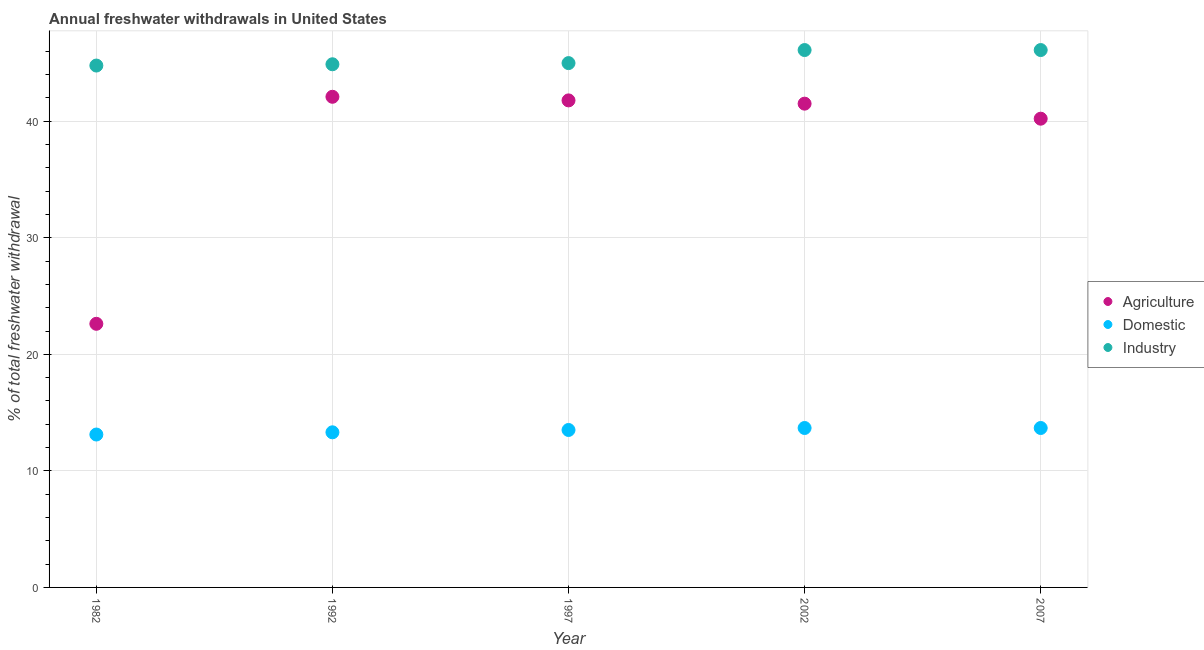Is the number of dotlines equal to the number of legend labels?
Your answer should be very brief. Yes. What is the percentage of freshwater withdrawal for industry in 2002?
Your response must be concise. 46.11. Across all years, what is the maximum percentage of freshwater withdrawal for agriculture?
Provide a succinct answer. 42.1. Across all years, what is the minimum percentage of freshwater withdrawal for agriculture?
Make the answer very short. 22.62. What is the total percentage of freshwater withdrawal for agriculture in the graph?
Your response must be concise. 188.24. What is the difference between the percentage of freshwater withdrawal for industry in 1997 and that in 2002?
Ensure brevity in your answer.  -1.12. What is the difference between the percentage of freshwater withdrawal for industry in 1982 and the percentage of freshwater withdrawal for domestic purposes in 2007?
Offer a terse response. 31.1. What is the average percentage of freshwater withdrawal for agriculture per year?
Offer a very short reply. 37.65. In the year 1992, what is the difference between the percentage of freshwater withdrawal for domestic purposes and percentage of freshwater withdrawal for agriculture?
Your answer should be compact. -28.79. In how many years, is the percentage of freshwater withdrawal for industry greater than 20 %?
Your answer should be very brief. 5. What is the ratio of the percentage of freshwater withdrawal for domestic purposes in 1992 to that in 2002?
Keep it short and to the point. 0.97. Is the difference between the percentage of freshwater withdrawal for agriculture in 1982 and 2002 greater than the difference between the percentage of freshwater withdrawal for domestic purposes in 1982 and 2002?
Your response must be concise. No. What is the difference between the highest and the second highest percentage of freshwater withdrawal for domestic purposes?
Make the answer very short. 0. What is the difference between the highest and the lowest percentage of freshwater withdrawal for agriculture?
Ensure brevity in your answer.  19.48. Is the sum of the percentage of freshwater withdrawal for industry in 1997 and 2002 greater than the maximum percentage of freshwater withdrawal for agriculture across all years?
Give a very brief answer. Yes. Is the percentage of freshwater withdrawal for industry strictly greater than the percentage of freshwater withdrawal for domestic purposes over the years?
Ensure brevity in your answer.  Yes. What is the difference between two consecutive major ticks on the Y-axis?
Your answer should be very brief. 10. How many legend labels are there?
Your response must be concise. 3. How are the legend labels stacked?
Keep it short and to the point. Vertical. What is the title of the graph?
Your response must be concise. Annual freshwater withdrawals in United States. Does "Wage workers" appear as one of the legend labels in the graph?
Keep it short and to the point. No. What is the label or title of the Y-axis?
Offer a very short reply. % of total freshwater withdrawal. What is the % of total freshwater withdrawal of Agriculture in 1982?
Give a very brief answer. 22.62. What is the % of total freshwater withdrawal in Domestic in 1982?
Ensure brevity in your answer.  13.12. What is the % of total freshwater withdrawal in Industry in 1982?
Provide a short and direct response. 44.78. What is the % of total freshwater withdrawal of Agriculture in 1992?
Offer a very short reply. 42.1. What is the % of total freshwater withdrawal in Domestic in 1992?
Provide a succinct answer. 13.31. What is the % of total freshwater withdrawal in Industry in 1992?
Provide a short and direct response. 44.89. What is the % of total freshwater withdrawal in Agriculture in 1997?
Give a very brief answer. 41.79. What is the % of total freshwater withdrawal of Domestic in 1997?
Your response must be concise. 13.51. What is the % of total freshwater withdrawal in Industry in 1997?
Ensure brevity in your answer.  44.99. What is the % of total freshwater withdrawal of Agriculture in 2002?
Your answer should be compact. 41.51. What is the % of total freshwater withdrawal of Domestic in 2002?
Offer a very short reply. 13.68. What is the % of total freshwater withdrawal of Industry in 2002?
Your response must be concise. 46.11. What is the % of total freshwater withdrawal of Agriculture in 2007?
Ensure brevity in your answer.  40.22. What is the % of total freshwater withdrawal in Domestic in 2007?
Give a very brief answer. 13.68. What is the % of total freshwater withdrawal in Industry in 2007?
Ensure brevity in your answer.  46.11. Across all years, what is the maximum % of total freshwater withdrawal in Agriculture?
Offer a very short reply. 42.1. Across all years, what is the maximum % of total freshwater withdrawal in Domestic?
Ensure brevity in your answer.  13.68. Across all years, what is the maximum % of total freshwater withdrawal in Industry?
Keep it short and to the point. 46.11. Across all years, what is the minimum % of total freshwater withdrawal in Agriculture?
Keep it short and to the point. 22.62. Across all years, what is the minimum % of total freshwater withdrawal of Domestic?
Give a very brief answer. 13.12. Across all years, what is the minimum % of total freshwater withdrawal of Industry?
Ensure brevity in your answer.  44.78. What is the total % of total freshwater withdrawal in Agriculture in the graph?
Ensure brevity in your answer.  188.24. What is the total % of total freshwater withdrawal of Domestic in the graph?
Your answer should be compact. 67.3. What is the total % of total freshwater withdrawal of Industry in the graph?
Provide a succinct answer. 226.88. What is the difference between the % of total freshwater withdrawal of Agriculture in 1982 and that in 1992?
Your answer should be very brief. -19.48. What is the difference between the % of total freshwater withdrawal of Domestic in 1982 and that in 1992?
Your answer should be very brief. -0.19. What is the difference between the % of total freshwater withdrawal of Industry in 1982 and that in 1992?
Make the answer very short. -0.11. What is the difference between the % of total freshwater withdrawal in Agriculture in 1982 and that in 1997?
Make the answer very short. -19.17. What is the difference between the % of total freshwater withdrawal of Domestic in 1982 and that in 1997?
Make the answer very short. -0.39. What is the difference between the % of total freshwater withdrawal in Industry in 1982 and that in 1997?
Offer a terse response. -0.21. What is the difference between the % of total freshwater withdrawal in Agriculture in 1982 and that in 2002?
Make the answer very short. -18.89. What is the difference between the % of total freshwater withdrawal of Domestic in 1982 and that in 2002?
Offer a very short reply. -0.56. What is the difference between the % of total freshwater withdrawal of Industry in 1982 and that in 2002?
Your answer should be very brief. -1.33. What is the difference between the % of total freshwater withdrawal of Agriculture in 1982 and that in 2007?
Give a very brief answer. -17.6. What is the difference between the % of total freshwater withdrawal of Domestic in 1982 and that in 2007?
Provide a succinct answer. -0.56. What is the difference between the % of total freshwater withdrawal of Industry in 1982 and that in 2007?
Give a very brief answer. -1.33. What is the difference between the % of total freshwater withdrawal of Agriculture in 1992 and that in 1997?
Your answer should be compact. 0.31. What is the difference between the % of total freshwater withdrawal of Domestic in 1992 and that in 1997?
Provide a succinct answer. -0.2. What is the difference between the % of total freshwater withdrawal in Agriculture in 1992 and that in 2002?
Provide a succinct answer. 0.59. What is the difference between the % of total freshwater withdrawal in Domestic in 1992 and that in 2002?
Make the answer very short. -0.37. What is the difference between the % of total freshwater withdrawal of Industry in 1992 and that in 2002?
Provide a short and direct response. -1.22. What is the difference between the % of total freshwater withdrawal in Agriculture in 1992 and that in 2007?
Make the answer very short. 1.88. What is the difference between the % of total freshwater withdrawal of Domestic in 1992 and that in 2007?
Your answer should be compact. -0.37. What is the difference between the % of total freshwater withdrawal in Industry in 1992 and that in 2007?
Offer a terse response. -1.22. What is the difference between the % of total freshwater withdrawal of Agriculture in 1997 and that in 2002?
Your response must be concise. 0.28. What is the difference between the % of total freshwater withdrawal of Domestic in 1997 and that in 2002?
Your answer should be very brief. -0.17. What is the difference between the % of total freshwater withdrawal in Industry in 1997 and that in 2002?
Your answer should be compact. -1.12. What is the difference between the % of total freshwater withdrawal of Agriculture in 1997 and that in 2007?
Your answer should be compact. 1.57. What is the difference between the % of total freshwater withdrawal of Domestic in 1997 and that in 2007?
Provide a succinct answer. -0.17. What is the difference between the % of total freshwater withdrawal in Industry in 1997 and that in 2007?
Provide a succinct answer. -1.12. What is the difference between the % of total freshwater withdrawal of Agriculture in 2002 and that in 2007?
Your answer should be compact. 1.29. What is the difference between the % of total freshwater withdrawal of Domestic in 2002 and that in 2007?
Provide a short and direct response. 0. What is the difference between the % of total freshwater withdrawal in Agriculture in 1982 and the % of total freshwater withdrawal in Domestic in 1992?
Your response must be concise. 9.31. What is the difference between the % of total freshwater withdrawal of Agriculture in 1982 and the % of total freshwater withdrawal of Industry in 1992?
Your answer should be compact. -22.27. What is the difference between the % of total freshwater withdrawal in Domestic in 1982 and the % of total freshwater withdrawal in Industry in 1992?
Offer a terse response. -31.77. What is the difference between the % of total freshwater withdrawal of Agriculture in 1982 and the % of total freshwater withdrawal of Domestic in 1997?
Offer a very short reply. 9.11. What is the difference between the % of total freshwater withdrawal of Agriculture in 1982 and the % of total freshwater withdrawal of Industry in 1997?
Offer a terse response. -22.37. What is the difference between the % of total freshwater withdrawal of Domestic in 1982 and the % of total freshwater withdrawal of Industry in 1997?
Make the answer very short. -31.87. What is the difference between the % of total freshwater withdrawal in Agriculture in 1982 and the % of total freshwater withdrawal in Domestic in 2002?
Offer a very short reply. 8.94. What is the difference between the % of total freshwater withdrawal of Agriculture in 1982 and the % of total freshwater withdrawal of Industry in 2002?
Provide a short and direct response. -23.49. What is the difference between the % of total freshwater withdrawal in Domestic in 1982 and the % of total freshwater withdrawal in Industry in 2002?
Make the answer very short. -32.99. What is the difference between the % of total freshwater withdrawal of Agriculture in 1982 and the % of total freshwater withdrawal of Domestic in 2007?
Keep it short and to the point. 8.94. What is the difference between the % of total freshwater withdrawal of Agriculture in 1982 and the % of total freshwater withdrawal of Industry in 2007?
Provide a short and direct response. -23.49. What is the difference between the % of total freshwater withdrawal in Domestic in 1982 and the % of total freshwater withdrawal in Industry in 2007?
Give a very brief answer. -32.99. What is the difference between the % of total freshwater withdrawal of Agriculture in 1992 and the % of total freshwater withdrawal of Domestic in 1997?
Your answer should be very brief. 28.59. What is the difference between the % of total freshwater withdrawal of Agriculture in 1992 and the % of total freshwater withdrawal of Industry in 1997?
Give a very brief answer. -2.89. What is the difference between the % of total freshwater withdrawal in Domestic in 1992 and the % of total freshwater withdrawal in Industry in 1997?
Provide a succinct answer. -31.68. What is the difference between the % of total freshwater withdrawal of Agriculture in 1992 and the % of total freshwater withdrawal of Domestic in 2002?
Your answer should be compact. 28.42. What is the difference between the % of total freshwater withdrawal in Agriculture in 1992 and the % of total freshwater withdrawal in Industry in 2002?
Provide a short and direct response. -4.01. What is the difference between the % of total freshwater withdrawal in Domestic in 1992 and the % of total freshwater withdrawal in Industry in 2002?
Keep it short and to the point. -32.8. What is the difference between the % of total freshwater withdrawal in Agriculture in 1992 and the % of total freshwater withdrawal in Domestic in 2007?
Provide a short and direct response. 28.42. What is the difference between the % of total freshwater withdrawal of Agriculture in 1992 and the % of total freshwater withdrawal of Industry in 2007?
Provide a succinct answer. -4.01. What is the difference between the % of total freshwater withdrawal of Domestic in 1992 and the % of total freshwater withdrawal of Industry in 2007?
Keep it short and to the point. -32.8. What is the difference between the % of total freshwater withdrawal in Agriculture in 1997 and the % of total freshwater withdrawal in Domestic in 2002?
Offer a very short reply. 28.11. What is the difference between the % of total freshwater withdrawal in Agriculture in 1997 and the % of total freshwater withdrawal in Industry in 2002?
Provide a short and direct response. -4.32. What is the difference between the % of total freshwater withdrawal of Domestic in 1997 and the % of total freshwater withdrawal of Industry in 2002?
Provide a short and direct response. -32.6. What is the difference between the % of total freshwater withdrawal of Agriculture in 1997 and the % of total freshwater withdrawal of Domestic in 2007?
Keep it short and to the point. 28.11. What is the difference between the % of total freshwater withdrawal of Agriculture in 1997 and the % of total freshwater withdrawal of Industry in 2007?
Provide a short and direct response. -4.32. What is the difference between the % of total freshwater withdrawal in Domestic in 1997 and the % of total freshwater withdrawal in Industry in 2007?
Offer a terse response. -32.6. What is the difference between the % of total freshwater withdrawal in Agriculture in 2002 and the % of total freshwater withdrawal in Domestic in 2007?
Offer a terse response. 27.83. What is the difference between the % of total freshwater withdrawal of Agriculture in 2002 and the % of total freshwater withdrawal of Industry in 2007?
Keep it short and to the point. -4.6. What is the difference between the % of total freshwater withdrawal of Domestic in 2002 and the % of total freshwater withdrawal of Industry in 2007?
Your response must be concise. -32.43. What is the average % of total freshwater withdrawal of Agriculture per year?
Offer a very short reply. 37.65. What is the average % of total freshwater withdrawal of Domestic per year?
Give a very brief answer. 13.46. What is the average % of total freshwater withdrawal of Industry per year?
Provide a short and direct response. 45.38. In the year 1982, what is the difference between the % of total freshwater withdrawal in Agriculture and % of total freshwater withdrawal in Industry?
Make the answer very short. -22.16. In the year 1982, what is the difference between the % of total freshwater withdrawal in Domestic and % of total freshwater withdrawal in Industry?
Offer a very short reply. -31.66. In the year 1992, what is the difference between the % of total freshwater withdrawal of Agriculture and % of total freshwater withdrawal of Domestic?
Your answer should be very brief. 28.79. In the year 1992, what is the difference between the % of total freshwater withdrawal of Agriculture and % of total freshwater withdrawal of Industry?
Provide a succinct answer. -2.79. In the year 1992, what is the difference between the % of total freshwater withdrawal in Domestic and % of total freshwater withdrawal in Industry?
Keep it short and to the point. -31.58. In the year 1997, what is the difference between the % of total freshwater withdrawal of Agriculture and % of total freshwater withdrawal of Domestic?
Offer a terse response. 28.28. In the year 1997, what is the difference between the % of total freshwater withdrawal in Agriculture and % of total freshwater withdrawal in Industry?
Make the answer very short. -3.2. In the year 1997, what is the difference between the % of total freshwater withdrawal of Domestic and % of total freshwater withdrawal of Industry?
Offer a terse response. -31.48. In the year 2002, what is the difference between the % of total freshwater withdrawal in Agriculture and % of total freshwater withdrawal in Domestic?
Provide a short and direct response. 27.83. In the year 2002, what is the difference between the % of total freshwater withdrawal in Domestic and % of total freshwater withdrawal in Industry?
Your answer should be very brief. -32.43. In the year 2007, what is the difference between the % of total freshwater withdrawal of Agriculture and % of total freshwater withdrawal of Domestic?
Provide a short and direct response. 26.54. In the year 2007, what is the difference between the % of total freshwater withdrawal in Agriculture and % of total freshwater withdrawal in Industry?
Your answer should be compact. -5.89. In the year 2007, what is the difference between the % of total freshwater withdrawal of Domestic and % of total freshwater withdrawal of Industry?
Your answer should be very brief. -32.43. What is the ratio of the % of total freshwater withdrawal in Agriculture in 1982 to that in 1992?
Your response must be concise. 0.54. What is the ratio of the % of total freshwater withdrawal in Domestic in 1982 to that in 1992?
Offer a very short reply. 0.99. What is the ratio of the % of total freshwater withdrawal in Industry in 1982 to that in 1992?
Offer a very short reply. 1. What is the ratio of the % of total freshwater withdrawal of Agriculture in 1982 to that in 1997?
Provide a succinct answer. 0.54. What is the ratio of the % of total freshwater withdrawal in Domestic in 1982 to that in 1997?
Your response must be concise. 0.97. What is the ratio of the % of total freshwater withdrawal in Industry in 1982 to that in 1997?
Make the answer very short. 1. What is the ratio of the % of total freshwater withdrawal of Agriculture in 1982 to that in 2002?
Keep it short and to the point. 0.54. What is the ratio of the % of total freshwater withdrawal of Domestic in 1982 to that in 2002?
Make the answer very short. 0.96. What is the ratio of the % of total freshwater withdrawal in Industry in 1982 to that in 2002?
Offer a terse response. 0.97. What is the ratio of the % of total freshwater withdrawal of Agriculture in 1982 to that in 2007?
Give a very brief answer. 0.56. What is the ratio of the % of total freshwater withdrawal in Domestic in 1982 to that in 2007?
Ensure brevity in your answer.  0.96. What is the ratio of the % of total freshwater withdrawal of Industry in 1982 to that in 2007?
Your answer should be very brief. 0.97. What is the ratio of the % of total freshwater withdrawal of Agriculture in 1992 to that in 1997?
Your answer should be compact. 1.01. What is the ratio of the % of total freshwater withdrawal of Domestic in 1992 to that in 1997?
Make the answer very short. 0.99. What is the ratio of the % of total freshwater withdrawal of Agriculture in 1992 to that in 2002?
Give a very brief answer. 1.01. What is the ratio of the % of total freshwater withdrawal in Industry in 1992 to that in 2002?
Make the answer very short. 0.97. What is the ratio of the % of total freshwater withdrawal of Agriculture in 1992 to that in 2007?
Offer a terse response. 1.05. What is the ratio of the % of total freshwater withdrawal in Industry in 1992 to that in 2007?
Your response must be concise. 0.97. What is the ratio of the % of total freshwater withdrawal of Domestic in 1997 to that in 2002?
Offer a very short reply. 0.99. What is the ratio of the % of total freshwater withdrawal in Industry in 1997 to that in 2002?
Give a very brief answer. 0.98. What is the ratio of the % of total freshwater withdrawal of Agriculture in 1997 to that in 2007?
Offer a very short reply. 1.04. What is the ratio of the % of total freshwater withdrawal in Domestic in 1997 to that in 2007?
Ensure brevity in your answer.  0.99. What is the ratio of the % of total freshwater withdrawal in Industry in 1997 to that in 2007?
Your answer should be very brief. 0.98. What is the ratio of the % of total freshwater withdrawal of Agriculture in 2002 to that in 2007?
Give a very brief answer. 1.03. What is the ratio of the % of total freshwater withdrawal of Domestic in 2002 to that in 2007?
Give a very brief answer. 1. What is the ratio of the % of total freshwater withdrawal of Industry in 2002 to that in 2007?
Ensure brevity in your answer.  1. What is the difference between the highest and the second highest % of total freshwater withdrawal in Agriculture?
Your response must be concise. 0.31. What is the difference between the highest and the lowest % of total freshwater withdrawal in Agriculture?
Your answer should be very brief. 19.48. What is the difference between the highest and the lowest % of total freshwater withdrawal of Domestic?
Your response must be concise. 0.56. What is the difference between the highest and the lowest % of total freshwater withdrawal in Industry?
Provide a succinct answer. 1.33. 